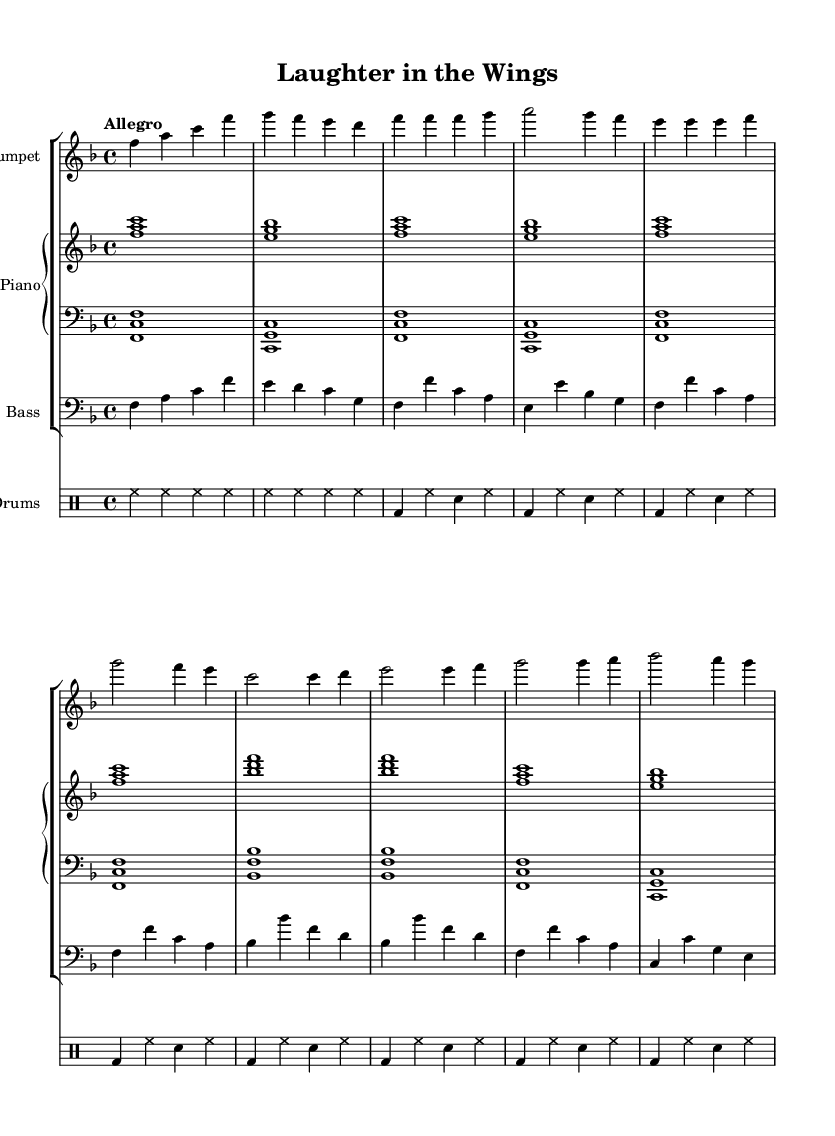What is the key signature of this music? The key signature is F major, which has one flat (B flat). This can be determined by checking the key signature section at the beginning of the sheet music.
Answer: F major What is the time signature of the piece? The time signature is 4/4. This is found in the notation at the beginning of the score, indicating four beats per measure and that a quarter note receives one beat.
Answer: 4/4 What is the tempo marking of the music? The tempo marking is "Allegro". This marking is indicated at the beginning of the score and tells us to play the piece quickly and lively.
Answer: Allegro How many measures are there in the "A Section"? The "A Section" consists of eight measures. Counting the measures as outlined in the scores for the A section specifically, from the beginning of that section to its ending confirms this number.
Answer: 8 Which instrument parts are included in the score? The score includes trumpet, piano (right and left hand), bass, and drums. By looking at the staff groupings in the score, we can identify each instrument presented through their respective staves.
Answer: Trumpet, piano, bass, drums What is the first note played by the trumpet? The first note played by the trumpet is F. This is indicated by the very first note in the trumpet music staff, which is the note F in the second octave.
Answer: F What type of musical form is utilized here, based on the sections labeled? The form used in this piece is A-B form. This is deduced from the labeling of the sections "A Section" and "B Section" in the score, which typically indicates a binary structure.
Answer: A-B form 